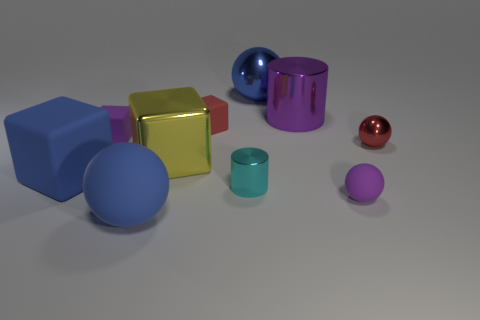Can you describe the shape of the objects in the image? Certainly! The image features a variety of shapes including a yellow cube, a red sphere, a blue cylinder, a teal torus, and a smaller pink sphere, among others. Each object has its own distinct geometry and color. 